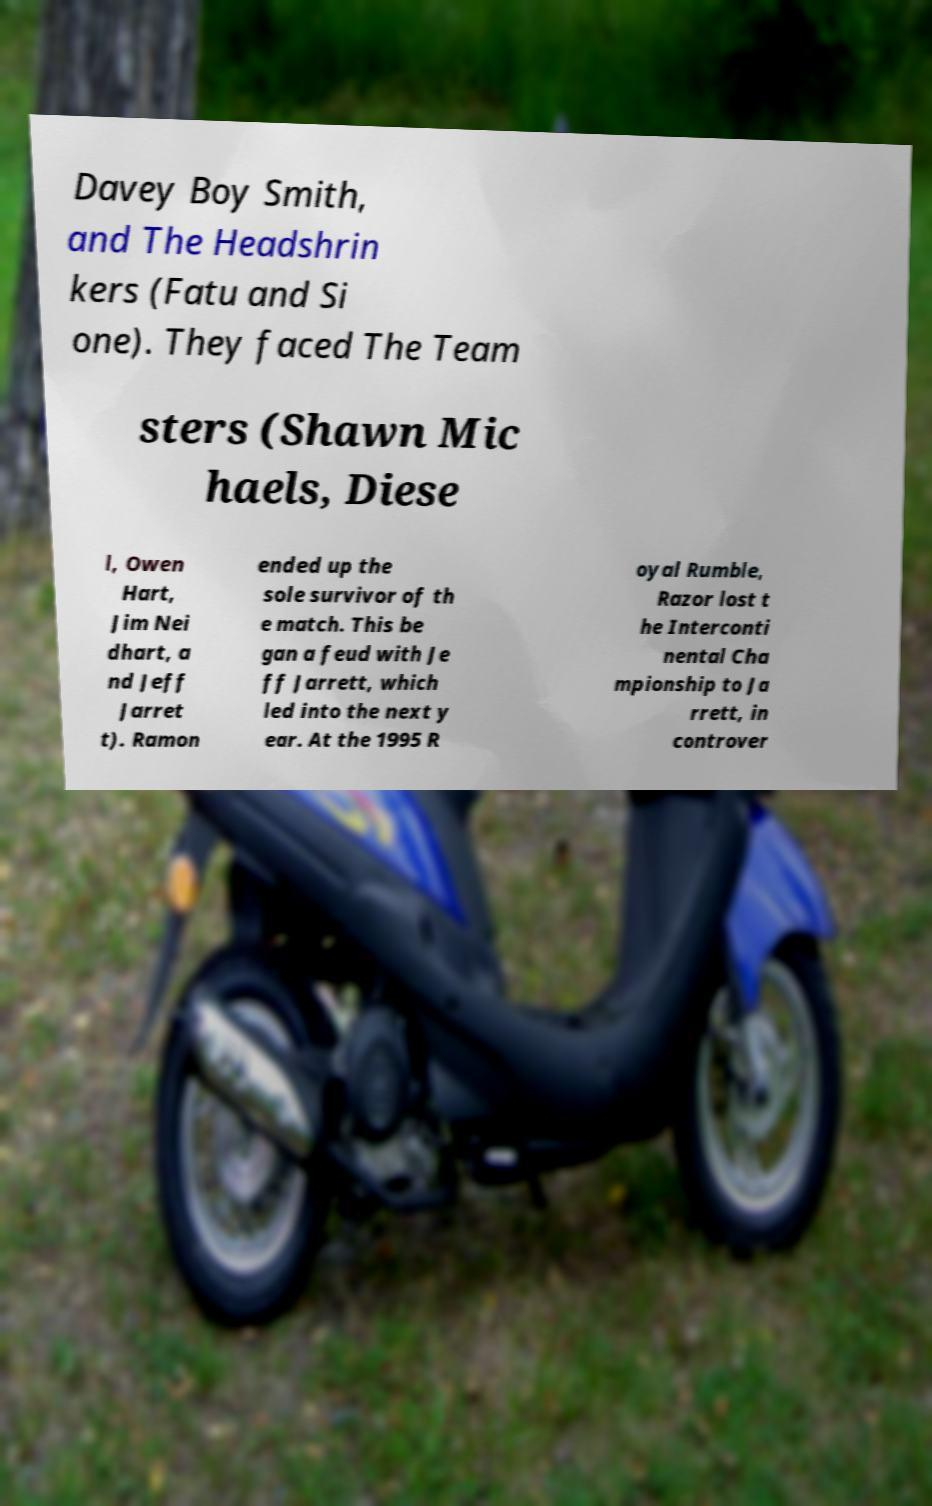What messages or text are displayed in this image? I need them in a readable, typed format. Davey Boy Smith, and The Headshrin kers (Fatu and Si one). They faced The Team sters (Shawn Mic haels, Diese l, Owen Hart, Jim Nei dhart, a nd Jeff Jarret t). Ramon ended up the sole survivor of th e match. This be gan a feud with Je ff Jarrett, which led into the next y ear. At the 1995 R oyal Rumble, Razor lost t he Interconti nental Cha mpionship to Ja rrett, in controver 